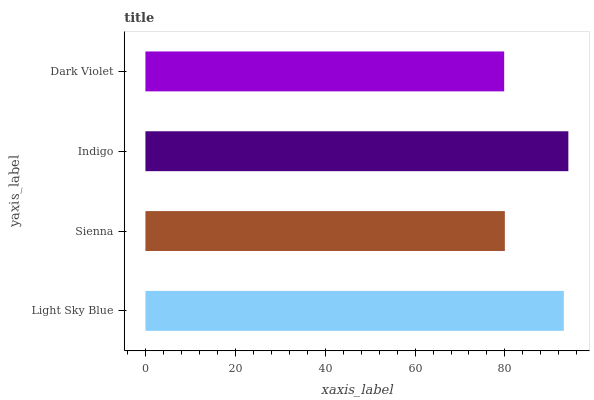Is Dark Violet the minimum?
Answer yes or no. Yes. Is Indigo the maximum?
Answer yes or no. Yes. Is Sienna the minimum?
Answer yes or no. No. Is Sienna the maximum?
Answer yes or no. No. Is Light Sky Blue greater than Sienna?
Answer yes or no. Yes. Is Sienna less than Light Sky Blue?
Answer yes or no. Yes. Is Sienna greater than Light Sky Blue?
Answer yes or no. No. Is Light Sky Blue less than Sienna?
Answer yes or no. No. Is Light Sky Blue the high median?
Answer yes or no. Yes. Is Sienna the low median?
Answer yes or no. Yes. Is Dark Violet the high median?
Answer yes or no. No. Is Indigo the low median?
Answer yes or no. No. 